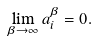<formula> <loc_0><loc_0><loc_500><loc_500>\lim _ { \beta \rightarrow \infty } a _ { i } ^ { \beta } = 0 .</formula> 